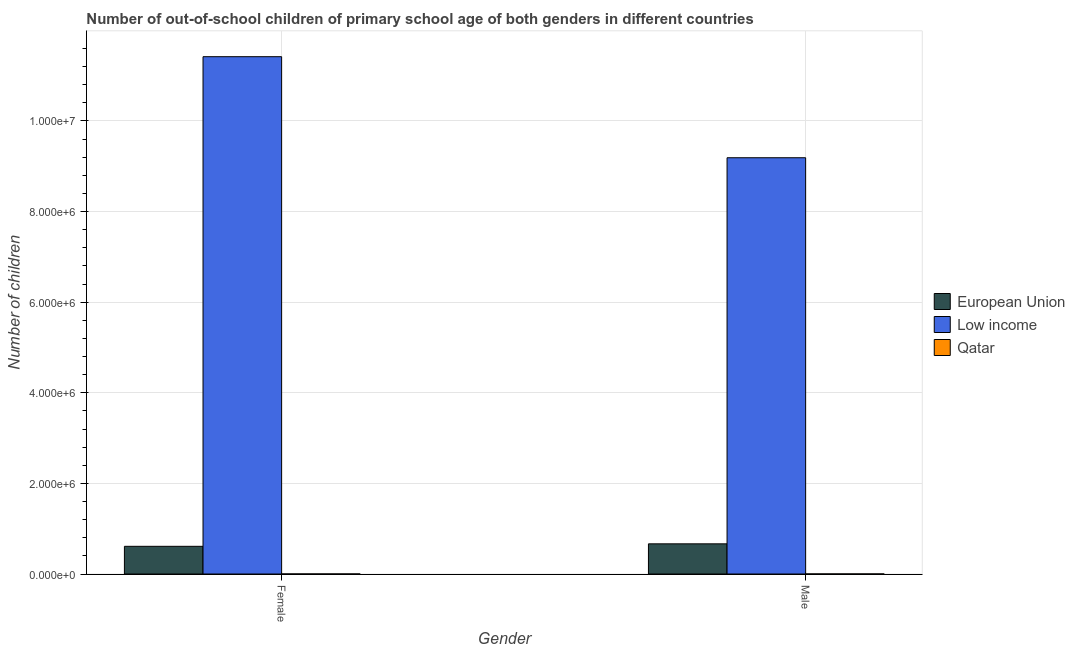How many different coloured bars are there?
Make the answer very short. 3. How many bars are there on the 2nd tick from the left?
Offer a terse response. 3. What is the label of the 2nd group of bars from the left?
Your answer should be compact. Male. What is the number of male out-of-school students in European Union?
Your answer should be very brief. 6.66e+05. Across all countries, what is the maximum number of female out-of-school students?
Keep it short and to the point. 1.14e+07. Across all countries, what is the minimum number of female out-of-school students?
Offer a very short reply. 845. In which country was the number of female out-of-school students minimum?
Your answer should be compact. Qatar. What is the total number of male out-of-school students in the graph?
Provide a succinct answer. 9.85e+06. What is the difference between the number of female out-of-school students in European Union and that in Low income?
Your answer should be compact. -1.08e+07. What is the difference between the number of male out-of-school students in European Union and the number of female out-of-school students in Qatar?
Offer a terse response. 6.65e+05. What is the average number of female out-of-school students per country?
Your answer should be very brief. 4.01e+06. What is the difference between the number of female out-of-school students and number of male out-of-school students in Low income?
Your answer should be compact. 2.23e+06. What is the ratio of the number of female out-of-school students in Qatar to that in Low income?
Your answer should be very brief. 7.401263207313324e-5. What does the 3rd bar from the left in Female represents?
Provide a short and direct response. Qatar. What does the 1st bar from the right in Female represents?
Offer a very short reply. Qatar. Are all the bars in the graph horizontal?
Offer a terse response. No. How many countries are there in the graph?
Provide a succinct answer. 3. What is the difference between two consecutive major ticks on the Y-axis?
Offer a terse response. 2.00e+06. Does the graph contain any zero values?
Your answer should be very brief. No. Does the graph contain grids?
Your answer should be very brief. Yes. What is the title of the graph?
Give a very brief answer. Number of out-of-school children of primary school age of both genders in different countries. What is the label or title of the Y-axis?
Give a very brief answer. Number of children. What is the Number of children in European Union in Female?
Your answer should be very brief. 6.11e+05. What is the Number of children in Low income in Female?
Give a very brief answer. 1.14e+07. What is the Number of children of Qatar in Female?
Your answer should be very brief. 845. What is the Number of children of European Union in Male?
Your answer should be compact. 6.66e+05. What is the Number of children of Low income in Male?
Offer a terse response. 9.19e+06. What is the Number of children in Qatar in Male?
Provide a succinct answer. 1303. Across all Gender, what is the maximum Number of children of European Union?
Your response must be concise. 6.66e+05. Across all Gender, what is the maximum Number of children in Low income?
Ensure brevity in your answer.  1.14e+07. Across all Gender, what is the maximum Number of children of Qatar?
Make the answer very short. 1303. Across all Gender, what is the minimum Number of children of European Union?
Give a very brief answer. 6.11e+05. Across all Gender, what is the minimum Number of children of Low income?
Keep it short and to the point. 9.19e+06. Across all Gender, what is the minimum Number of children of Qatar?
Your answer should be very brief. 845. What is the total Number of children of European Union in the graph?
Your answer should be very brief. 1.28e+06. What is the total Number of children in Low income in the graph?
Make the answer very short. 2.06e+07. What is the total Number of children in Qatar in the graph?
Make the answer very short. 2148. What is the difference between the Number of children of European Union in Female and that in Male?
Offer a terse response. -5.49e+04. What is the difference between the Number of children of Low income in Female and that in Male?
Give a very brief answer. 2.23e+06. What is the difference between the Number of children of Qatar in Female and that in Male?
Your response must be concise. -458. What is the difference between the Number of children in European Union in Female and the Number of children in Low income in Male?
Provide a short and direct response. -8.58e+06. What is the difference between the Number of children of European Union in Female and the Number of children of Qatar in Male?
Make the answer very short. 6.10e+05. What is the difference between the Number of children in Low income in Female and the Number of children in Qatar in Male?
Your answer should be compact. 1.14e+07. What is the average Number of children in European Union per Gender?
Offer a terse response. 6.38e+05. What is the average Number of children of Low income per Gender?
Give a very brief answer. 1.03e+07. What is the average Number of children of Qatar per Gender?
Your answer should be very brief. 1074. What is the difference between the Number of children of European Union and Number of children of Low income in Female?
Make the answer very short. -1.08e+07. What is the difference between the Number of children in European Union and Number of children in Qatar in Female?
Your response must be concise. 6.10e+05. What is the difference between the Number of children in Low income and Number of children in Qatar in Female?
Your response must be concise. 1.14e+07. What is the difference between the Number of children in European Union and Number of children in Low income in Male?
Ensure brevity in your answer.  -8.52e+06. What is the difference between the Number of children of European Union and Number of children of Qatar in Male?
Provide a short and direct response. 6.64e+05. What is the difference between the Number of children of Low income and Number of children of Qatar in Male?
Offer a very short reply. 9.19e+06. What is the ratio of the Number of children of European Union in Female to that in Male?
Your answer should be very brief. 0.92. What is the ratio of the Number of children of Low income in Female to that in Male?
Ensure brevity in your answer.  1.24. What is the ratio of the Number of children of Qatar in Female to that in Male?
Provide a short and direct response. 0.65. What is the difference between the highest and the second highest Number of children of European Union?
Provide a succinct answer. 5.49e+04. What is the difference between the highest and the second highest Number of children in Low income?
Your answer should be very brief. 2.23e+06. What is the difference between the highest and the second highest Number of children of Qatar?
Give a very brief answer. 458. What is the difference between the highest and the lowest Number of children in European Union?
Ensure brevity in your answer.  5.49e+04. What is the difference between the highest and the lowest Number of children in Low income?
Offer a very short reply. 2.23e+06. What is the difference between the highest and the lowest Number of children in Qatar?
Your answer should be very brief. 458. 